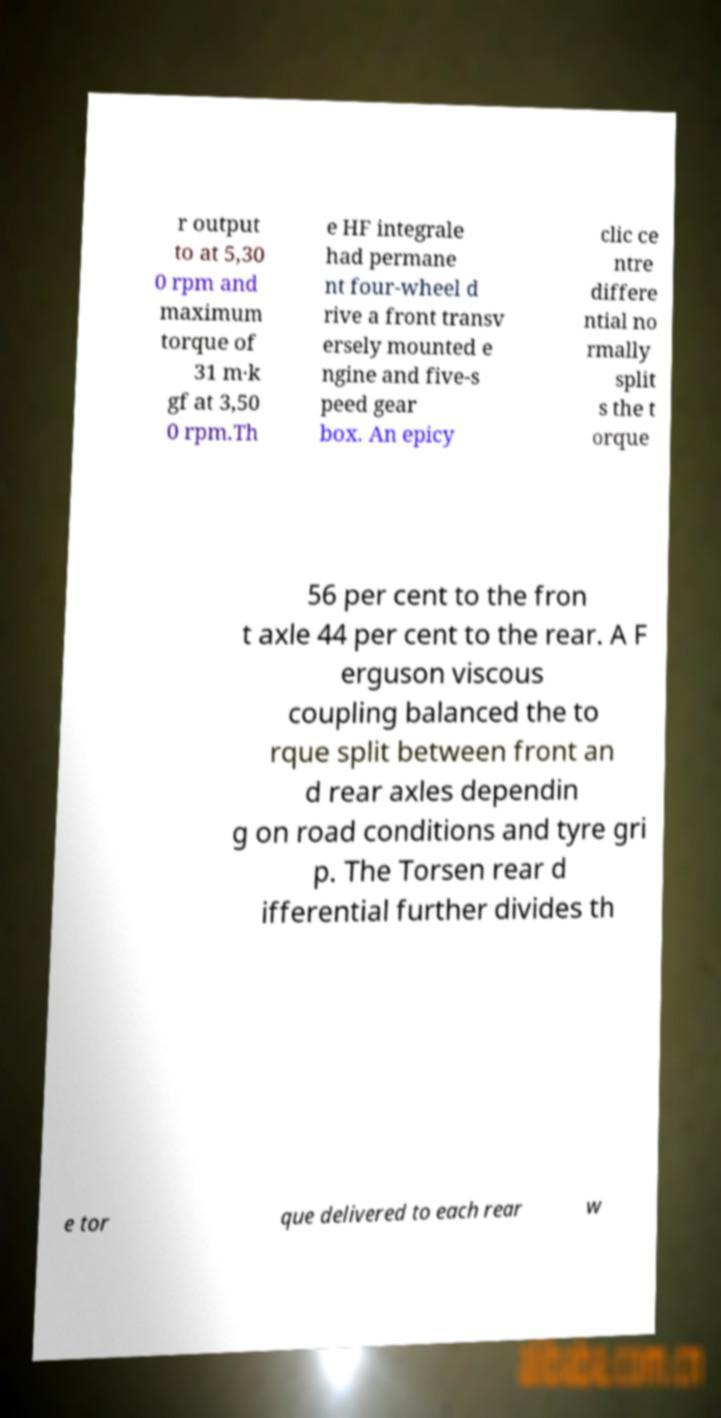Please identify and transcribe the text found in this image. r output to at 5,30 0 rpm and maximum torque of 31 m·k gf at 3,50 0 rpm.Th e HF integrale had permane nt four-wheel d rive a front transv ersely mounted e ngine and five-s peed gear box. An epicy clic ce ntre differe ntial no rmally split s the t orque 56 per cent to the fron t axle 44 per cent to the rear. A F erguson viscous coupling balanced the to rque split between front an d rear axles dependin g on road conditions and tyre gri p. The Torsen rear d ifferential further divides th e tor que delivered to each rear w 